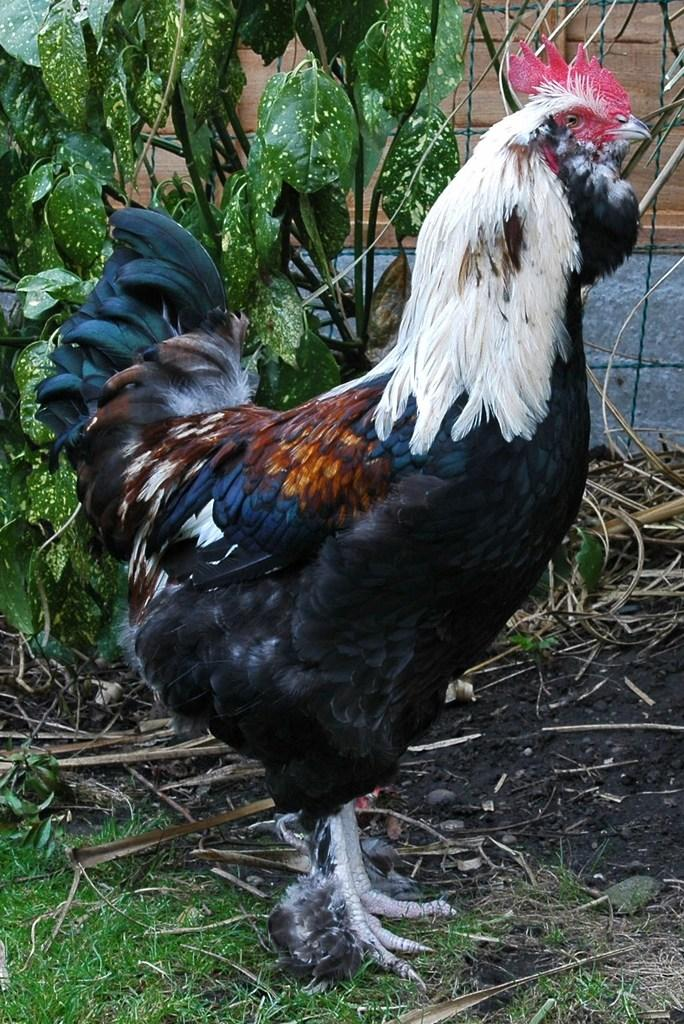What animal is in the front of the image? There is a rooster in the front of the image. What type of vegetation is at the bottom of the image? There is grass at the bottom of the image. What other types of vegetation can be seen in the image? There are plants visible in the image. What is located in the background of the image? There is a wall in the background of the image. What year is depicted in the image? There is no specific year depicted in the image; it is a static scene featuring a rooster, grass, plants, and a wall. 